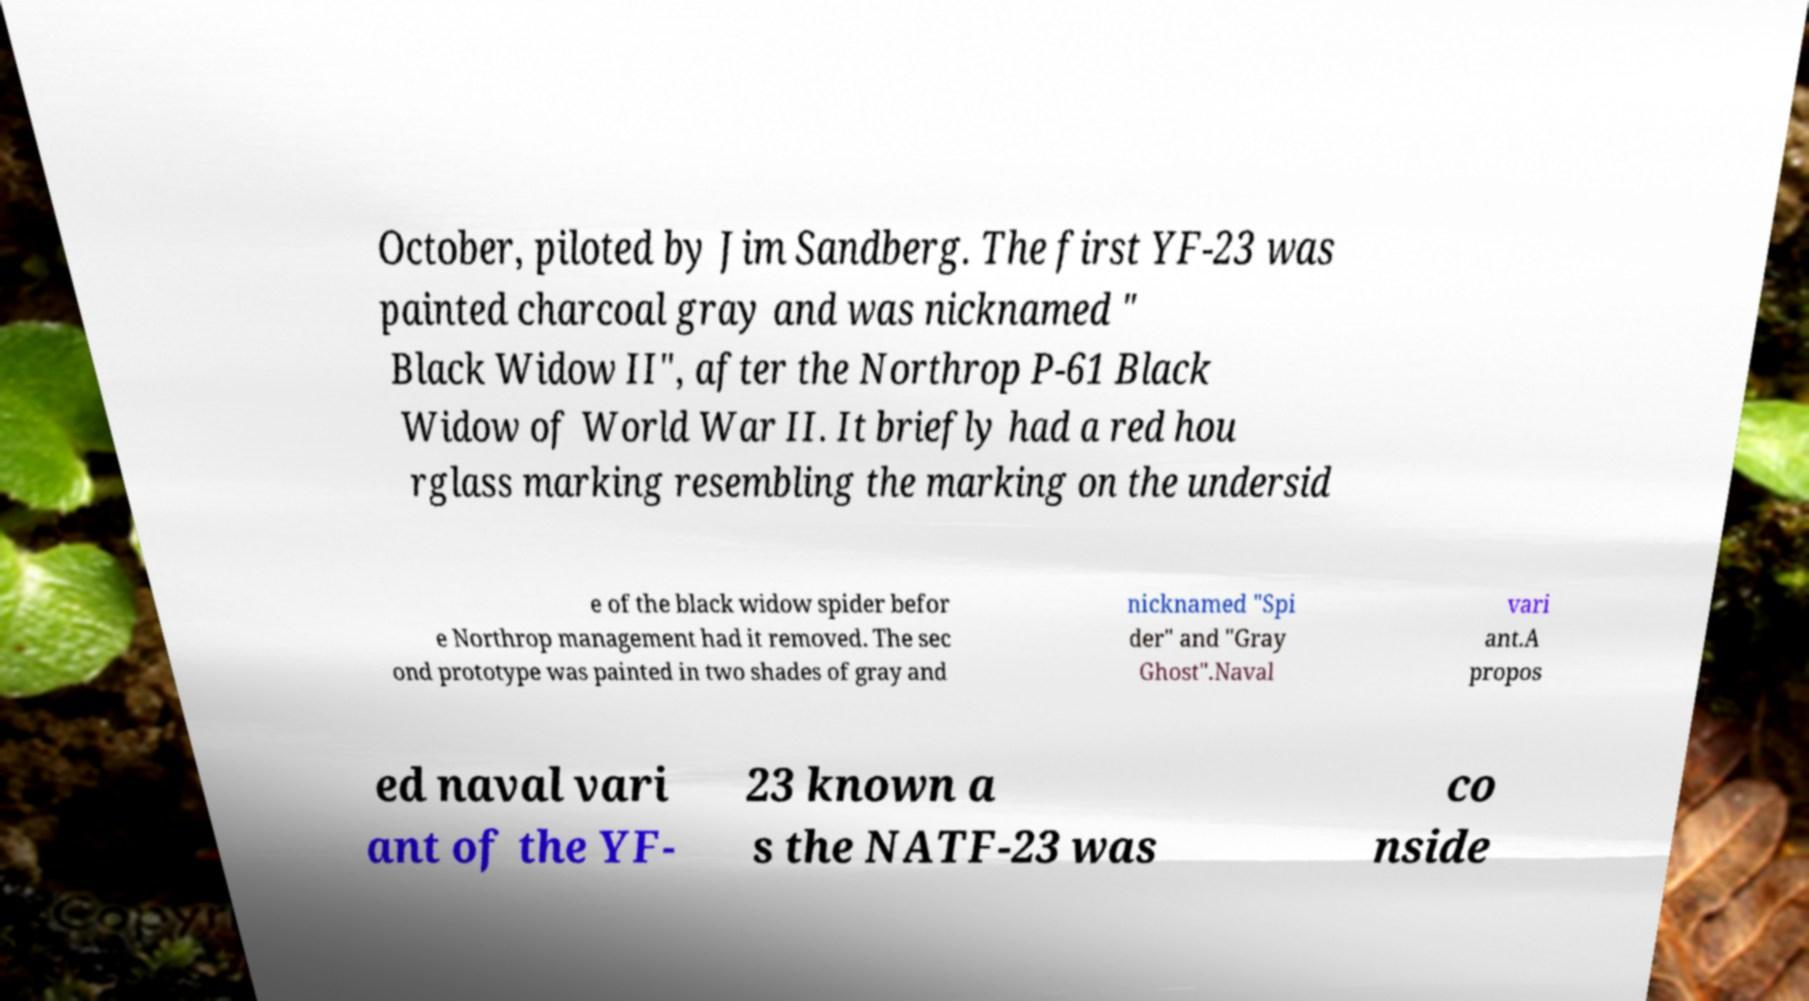Can you accurately transcribe the text from the provided image for me? October, piloted by Jim Sandberg. The first YF-23 was painted charcoal gray and was nicknamed " Black Widow II", after the Northrop P-61 Black Widow of World War II. It briefly had a red hou rglass marking resembling the marking on the undersid e of the black widow spider befor e Northrop management had it removed. The sec ond prototype was painted in two shades of gray and nicknamed "Spi der" and "Gray Ghost".Naval vari ant.A propos ed naval vari ant of the YF- 23 known a s the NATF-23 was co nside 